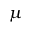<formula> <loc_0><loc_0><loc_500><loc_500>\mu</formula> 